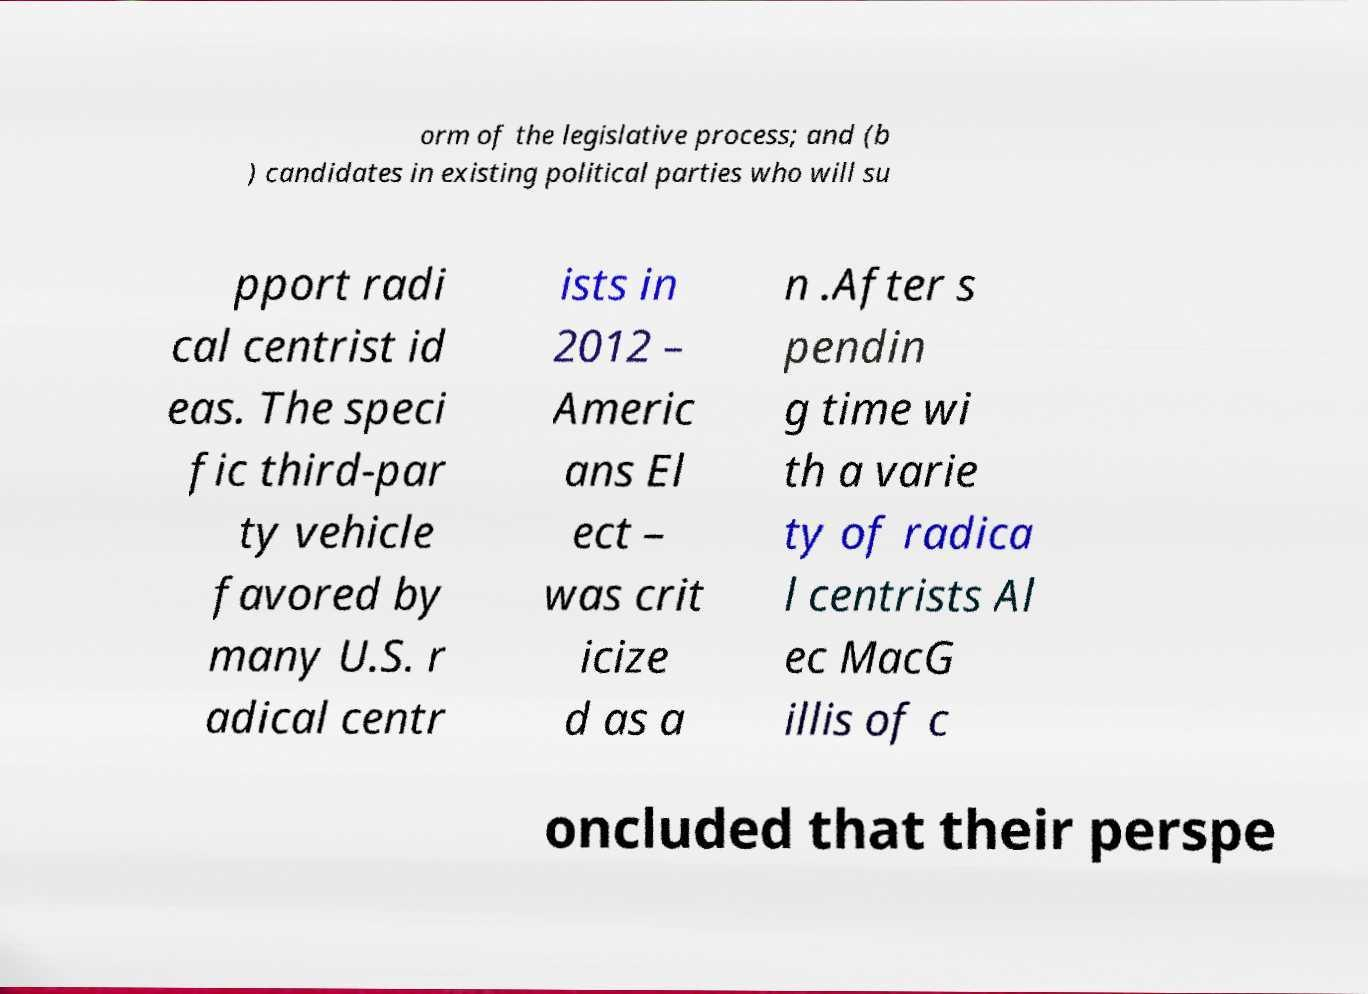Could you extract and type out the text from this image? orm of the legislative process; and (b ) candidates in existing political parties who will su pport radi cal centrist id eas. The speci fic third-par ty vehicle favored by many U.S. r adical centr ists in 2012 – Americ ans El ect – was crit icize d as a n .After s pendin g time wi th a varie ty of radica l centrists Al ec MacG illis of c oncluded that their perspe 